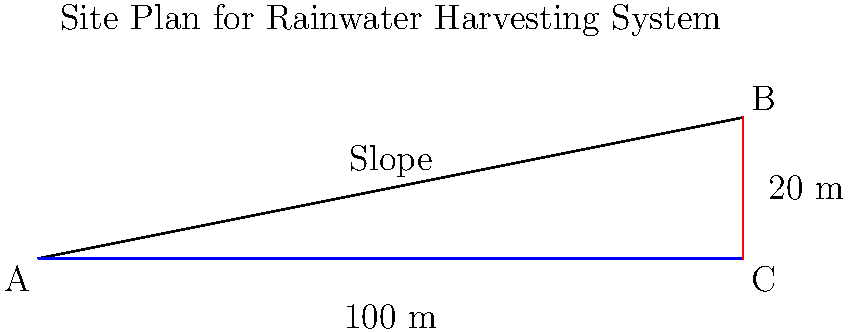Using the site plan provided, calculate the slope of the land from point A to point B. If a minimum slope of 2% is required for proper drainage in a rainwater harvesting system, does this site meet the requirement? If not, what is the minimum horizontal distance needed to achieve a 2% slope while maintaining the same vertical rise? To solve this problem, we'll follow these steps:

1. Calculate the slope:
   Slope = (Rise / Run) × 100%
   
   From the site plan:
   Rise = 20 m
   Run = 100 m
   
   Slope = (20 m / 100 m) × 100% = 20%

2. Compare the calculated slope to the minimum requirement:
   Calculated slope: 20%
   Minimum required slope: 2%
   
   20% > 2%, so the site meets the minimum slope requirement.

3. Since the site already meets the requirement, we don't need to calculate the minimum horizontal distance for a 2% slope. However, for educational purposes, let's calculate it:

   For a 2% slope:
   2% = (20 m / x) × 100%
   0.02 = 20 m / x
   x = 20 m / 0.02 = 1000 m

   This means that if the slope were only 2%, the horizontal distance would need to be 1000 m to achieve the same 20 m vertical rise.
Answer: Slope: 20%; Site meets requirement 